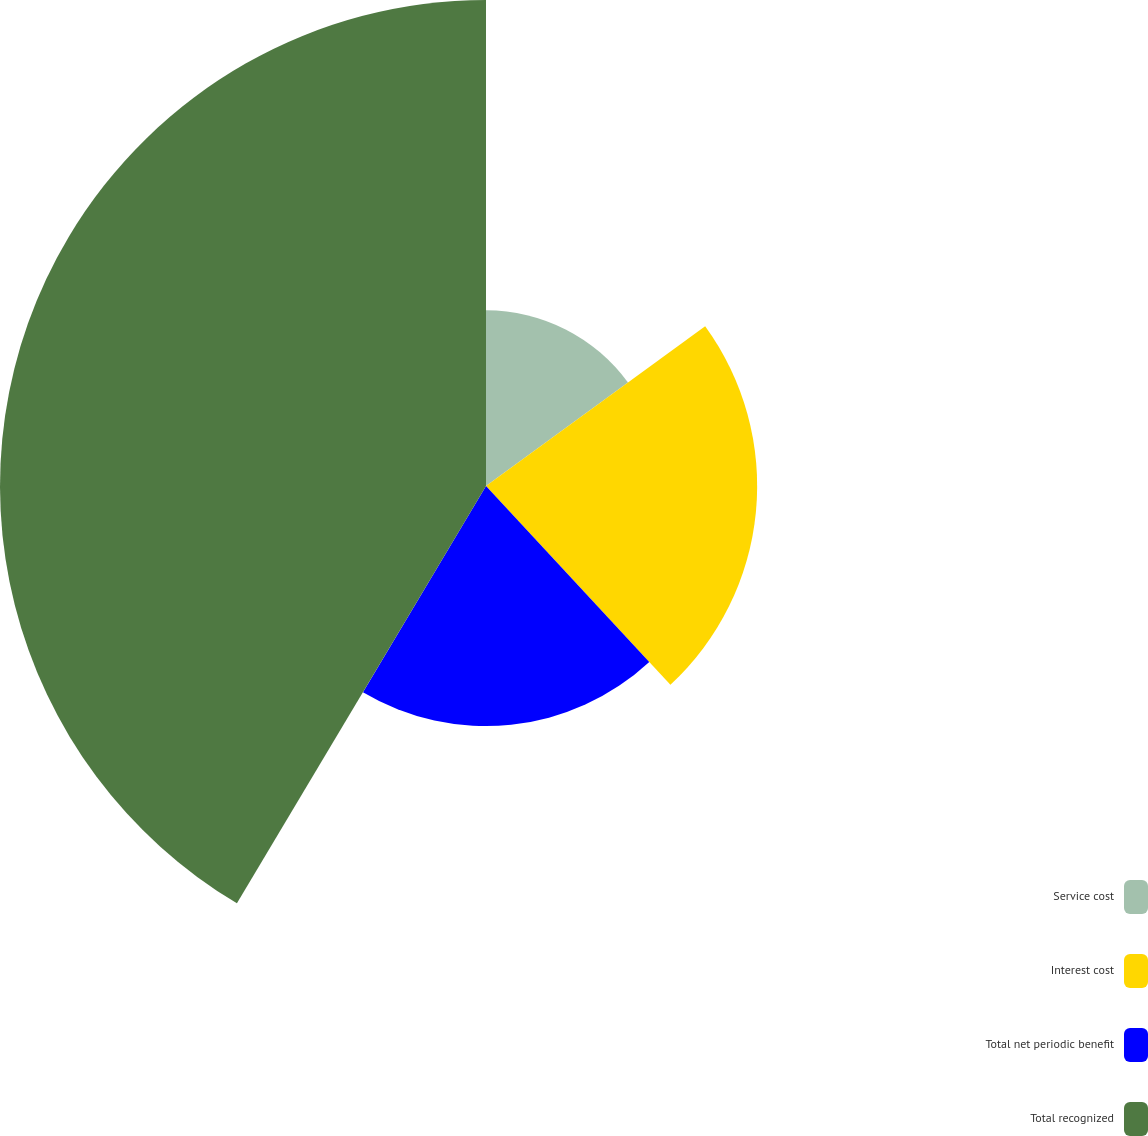Convert chart to OTSL. <chart><loc_0><loc_0><loc_500><loc_500><pie_chart><fcel>Service cost<fcel>Interest cost<fcel>Total net periodic benefit<fcel>Total recognized<nl><fcel>14.98%<fcel>23.12%<fcel>20.47%<fcel>41.44%<nl></chart> 